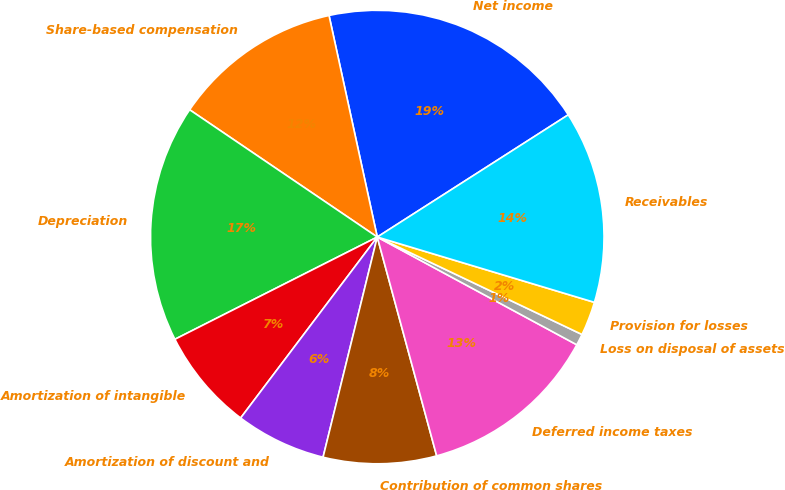Convert chart to OTSL. <chart><loc_0><loc_0><loc_500><loc_500><pie_chart><fcel>Net income<fcel>Share-based compensation<fcel>Depreciation<fcel>Amortization of intangible<fcel>Amortization of discount and<fcel>Contribution of common shares<fcel>Deferred income taxes<fcel>Loss on disposal of assets<fcel>Provision for losses<fcel>Receivables<nl><fcel>19.35%<fcel>12.1%<fcel>16.93%<fcel>7.26%<fcel>6.45%<fcel>8.06%<fcel>12.9%<fcel>0.81%<fcel>2.42%<fcel>13.71%<nl></chart> 